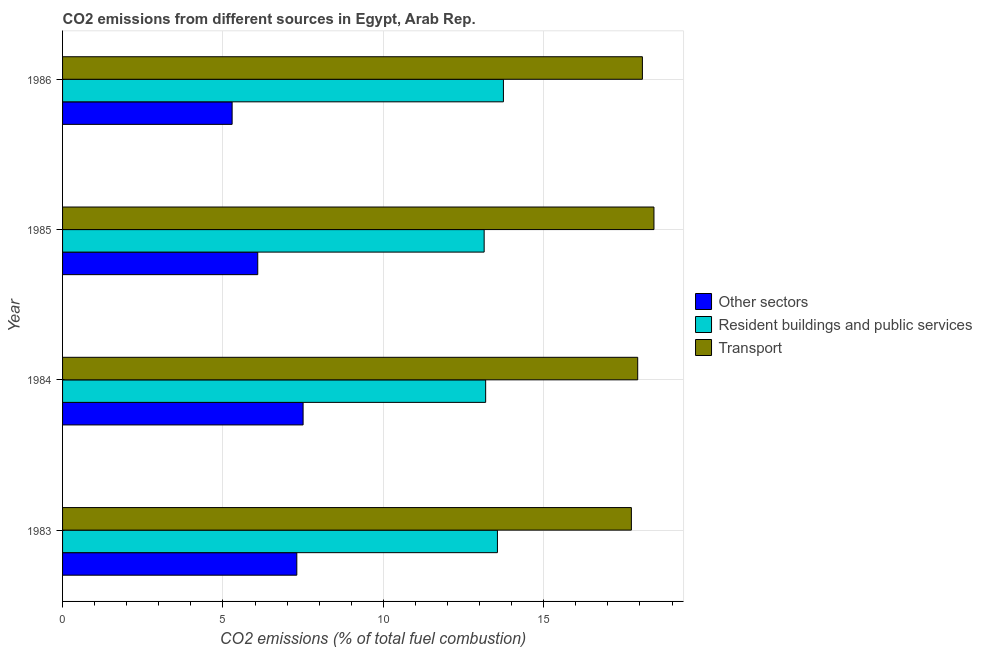Are the number of bars per tick equal to the number of legend labels?
Offer a terse response. Yes. How many bars are there on the 3rd tick from the top?
Offer a very short reply. 3. In how many cases, is the number of bars for a given year not equal to the number of legend labels?
Ensure brevity in your answer.  0. What is the percentage of co2 emissions from other sectors in 1986?
Your answer should be very brief. 5.29. Across all years, what is the maximum percentage of co2 emissions from other sectors?
Your answer should be compact. 7.5. Across all years, what is the minimum percentage of co2 emissions from resident buildings and public services?
Keep it short and to the point. 13.14. In which year was the percentage of co2 emissions from resident buildings and public services maximum?
Offer a terse response. 1986. In which year was the percentage of co2 emissions from transport minimum?
Ensure brevity in your answer.  1983. What is the total percentage of co2 emissions from other sectors in the graph?
Your answer should be very brief. 26.17. What is the difference between the percentage of co2 emissions from resident buildings and public services in 1983 and that in 1984?
Offer a very short reply. 0.37. What is the difference between the percentage of co2 emissions from resident buildings and public services in 1984 and the percentage of co2 emissions from other sectors in 1983?
Provide a succinct answer. 5.89. What is the average percentage of co2 emissions from resident buildings and public services per year?
Offer a very short reply. 13.41. In the year 1985, what is the difference between the percentage of co2 emissions from transport and percentage of co2 emissions from resident buildings and public services?
Make the answer very short. 5.29. What is the ratio of the percentage of co2 emissions from other sectors in 1984 to that in 1985?
Keep it short and to the point. 1.23. Is the difference between the percentage of co2 emissions from resident buildings and public services in 1983 and 1985 greater than the difference between the percentage of co2 emissions from transport in 1983 and 1985?
Your response must be concise. Yes. What is the difference between the highest and the second highest percentage of co2 emissions from resident buildings and public services?
Offer a terse response. 0.19. What is the difference between the highest and the lowest percentage of co2 emissions from resident buildings and public services?
Your response must be concise. 0.6. Is the sum of the percentage of co2 emissions from resident buildings and public services in 1985 and 1986 greater than the maximum percentage of co2 emissions from transport across all years?
Provide a short and direct response. Yes. What does the 1st bar from the top in 1986 represents?
Ensure brevity in your answer.  Transport. What does the 3rd bar from the bottom in 1985 represents?
Make the answer very short. Transport. How many bars are there?
Ensure brevity in your answer.  12. How many years are there in the graph?
Make the answer very short. 4. Are the values on the major ticks of X-axis written in scientific E-notation?
Provide a succinct answer. No. What is the title of the graph?
Provide a succinct answer. CO2 emissions from different sources in Egypt, Arab Rep. What is the label or title of the X-axis?
Provide a short and direct response. CO2 emissions (% of total fuel combustion). What is the label or title of the Y-axis?
Keep it short and to the point. Year. What is the CO2 emissions (% of total fuel combustion) in Other sectors in 1983?
Your response must be concise. 7.3. What is the CO2 emissions (% of total fuel combustion) in Resident buildings and public services in 1983?
Your response must be concise. 13.56. What is the CO2 emissions (% of total fuel combustion) in Transport in 1983?
Your answer should be compact. 17.73. What is the CO2 emissions (% of total fuel combustion) in Other sectors in 1984?
Ensure brevity in your answer.  7.5. What is the CO2 emissions (% of total fuel combustion) in Resident buildings and public services in 1984?
Offer a terse response. 13.19. What is the CO2 emissions (% of total fuel combustion) of Transport in 1984?
Offer a terse response. 17.93. What is the CO2 emissions (% of total fuel combustion) of Other sectors in 1985?
Give a very brief answer. 6.08. What is the CO2 emissions (% of total fuel combustion) in Resident buildings and public services in 1985?
Your answer should be very brief. 13.14. What is the CO2 emissions (% of total fuel combustion) of Transport in 1985?
Your response must be concise. 18.44. What is the CO2 emissions (% of total fuel combustion) of Other sectors in 1986?
Provide a short and direct response. 5.29. What is the CO2 emissions (% of total fuel combustion) of Resident buildings and public services in 1986?
Give a very brief answer. 13.74. What is the CO2 emissions (% of total fuel combustion) of Transport in 1986?
Make the answer very short. 18.08. Across all years, what is the maximum CO2 emissions (% of total fuel combustion) of Other sectors?
Make the answer very short. 7.5. Across all years, what is the maximum CO2 emissions (% of total fuel combustion) in Resident buildings and public services?
Give a very brief answer. 13.74. Across all years, what is the maximum CO2 emissions (% of total fuel combustion) in Transport?
Keep it short and to the point. 18.44. Across all years, what is the minimum CO2 emissions (% of total fuel combustion) in Other sectors?
Offer a very short reply. 5.29. Across all years, what is the minimum CO2 emissions (% of total fuel combustion) in Resident buildings and public services?
Give a very brief answer. 13.14. Across all years, what is the minimum CO2 emissions (% of total fuel combustion) of Transport?
Make the answer very short. 17.73. What is the total CO2 emissions (% of total fuel combustion) of Other sectors in the graph?
Provide a short and direct response. 26.17. What is the total CO2 emissions (% of total fuel combustion) of Resident buildings and public services in the graph?
Provide a short and direct response. 53.63. What is the total CO2 emissions (% of total fuel combustion) of Transport in the graph?
Your answer should be very brief. 72.17. What is the difference between the CO2 emissions (% of total fuel combustion) of Other sectors in 1983 and that in 1984?
Your response must be concise. -0.2. What is the difference between the CO2 emissions (% of total fuel combustion) in Resident buildings and public services in 1983 and that in 1984?
Offer a very short reply. 0.37. What is the difference between the CO2 emissions (% of total fuel combustion) in Transport in 1983 and that in 1984?
Provide a short and direct response. -0.2. What is the difference between the CO2 emissions (% of total fuel combustion) in Other sectors in 1983 and that in 1985?
Keep it short and to the point. 1.22. What is the difference between the CO2 emissions (% of total fuel combustion) of Resident buildings and public services in 1983 and that in 1985?
Your response must be concise. 0.41. What is the difference between the CO2 emissions (% of total fuel combustion) of Transport in 1983 and that in 1985?
Provide a short and direct response. -0.7. What is the difference between the CO2 emissions (% of total fuel combustion) of Other sectors in 1983 and that in 1986?
Offer a very short reply. 2.02. What is the difference between the CO2 emissions (% of total fuel combustion) in Resident buildings and public services in 1983 and that in 1986?
Provide a succinct answer. -0.19. What is the difference between the CO2 emissions (% of total fuel combustion) in Transport in 1983 and that in 1986?
Ensure brevity in your answer.  -0.34. What is the difference between the CO2 emissions (% of total fuel combustion) in Other sectors in 1984 and that in 1985?
Keep it short and to the point. 1.41. What is the difference between the CO2 emissions (% of total fuel combustion) of Resident buildings and public services in 1984 and that in 1985?
Provide a succinct answer. 0.05. What is the difference between the CO2 emissions (% of total fuel combustion) in Transport in 1984 and that in 1985?
Offer a terse response. -0.51. What is the difference between the CO2 emissions (% of total fuel combustion) of Other sectors in 1984 and that in 1986?
Offer a very short reply. 2.21. What is the difference between the CO2 emissions (% of total fuel combustion) in Resident buildings and public services in 1984 and that in 1986?
Your answer should be very brief. -0.55. What is the difference between the CO2 emissions (% of total fuel combustion) of Transport in 1984 and that in 1986?
Offer a very short reply. -0.15. What is the difference between the CO2 emissions (% of total fuel combustion) in Other sectors in 1985 and that in 1986?
Provide a short and direct response. 0.8. What is the difference between the CO2 emissions (% of total fuel combustion) of Resident buildings and public services in 1985 and that in 1986?
Offer a very short reply. -0.6. What is the difference between the CO2 emissions (% of total fuel combustion) of Transport in 1985 and that in 1986?
Offer a terse response. 0.36. What is the difference between the CO2 emissions (% of total fuel combustion) of Other sectors in 1983 and the CO2 emissions (% of total fuel combustion) of Resident buildings and public services in 1984?
Provide a succinct answer. -5.89. What is the difference between the CO2 emissions (% of total fuel combustion) in Other sectors in 1983 and the CO2 emissions (% of total fuel combustion) in Transport in 1984?
Give a very brief answer. -10.63. What is the difference between the CO2 emissions (% of total fuel combustion) of Resident buildings and public services in 1983 and the CO2 emissions (% of total fuel combustion) of Transport in 1984?
Ensure brevity in your answer.  -4.37. What is the difference between the CO2 emissions (% of total fuel combustion) in Other sectors in 1983 and the CO2 emissions (% of total fuel combustion) in Resident buildings and public services in 1985?
Your response must be concise. -5.84. What is the difference between the CO2 emissions (% of total fuel combustion) of Other sectors in 1983 and the CO2 emissions (% of total fuel combustion) of Transport in 1985?
Provide a short and direct response. -11.13. What is the difference between the CO2 emissions (% of total fuel combustion) in Resident buildings and public services in 1983 and the CO2 emissions (% of total fuel combustion) in Transport in 1985?
Keep it short and to the point. -4.88. What is the difference between the CO2 emissions (% of total fuel combustion) in Other sectors in 1983 and the CO2 emissions (% of total fuel combustion) in Resident buildings and public services in 1986?
Give a very brief answer. -6.44. What is the difference between the CO2 emissions (% of total fuel combustion) of Other sectors in 1983 and the CO2 emissions (% of total fuel combustion) of Transport in 1986?
Offer a terse response. -10.77. What is the difference between the CO2 emissions (% of total fuel combustion) in Resident buildings and public services in 1983 and the CO2 emissions (% of total fuel combustion) in Transport in 1986?
Offer a very short reply. -4.52. What is the difference between the CO2 emissions (% of total fuel combustion) of Other sectors in 1984 and the CO2 emissions (% of total fuel combustion) of Resident buildings and public services in 1985?
Give a very brief answer. -5.64. What is the difference between the CO2 emissions (% of total fuel combustion) of Other sectors in 1984 and the CO2 emissions (% of total fuel combustion) of Transport in 1985?
Offer a very short reply. -10.94. What is the difference between the CO2 emissions (% of total fuel combustion) of Resident buildings and public services in 1984 and the CO2 emissions (% of total fuel combustion) of Transport in 1985?
Give a very brief answer. -5.25. What is the difference between the CO2 emissions (% of total fuel combustion) in Other sectors in 1984 and the CO2 emissions (% of total fuel combustion) in Resident buildings and public services in 1986?
Your answer should be very brief. -6.24. What is the difference between the CO2 emissions (% of total fuel combustion) in Other sectors in 1984 and the CO2 emissions (% of total fuel combustion) in Transport in 1986?
Offer a terse response. -10.58. What is the difference between the CO2 emissions (% of total fuel combustion) in Resident buildings and public services in 1984 and the CO2 emissions (% of total fuel combustion) in Transport in 1986?
Your answer should be compact. -4.89. What is the difference between the CO2 emissions (% of total fuel combustion) in Other sectors in 1985 and the CO2 emissions (% of total fuel combustion) in Resident buildings and public services in 1986?
Keep it short and to the point. -7.66. What is the difference between the CO2 emissions (% of total fuel combustion) in Other sectors in 1985 and the CO2 emissions (% of total fuel combustion) in Transport in 1986?
Give a very brief answer. -11.99. What is the difference between the CO2 emissions (% of total fuel combustion) in Resident buildings and public services in 1985 and the CO2 emissions (% of total fuel combustion) in Transport in 1986?
Offer a very short reply. -4.93. What is the average CO2 emissions (% of total fuel combustion) of Other sectors per year?
Your answer should be compact. 6.54. What is the average CO2 emissions (% of total fuel combustion) of Resident buildings and public services per year?
Offer a terse response. 13.41. What is the average CO2 emissions (% of total fuel combustion) in Transport per year?
Your response must be concise. 18.04. In the year 1983, what is the difference between the CO2 emissions (% of total fuel combustion) in Other sectors and CO2 emissions (% of total fuel combustion) in Resident buildings and public services?
Provide a succinct answer. -6.25. In the year 1983, what is the difference between the CO2 emissions (% of total fuel combustion) of Other sectors and CO2 emissions (% of total fuel combustion) of Transport?
Your answer should be very brief. -10.43. In the year 1983, what is the difference between the CO2 emissions (% of total fuel combustion) of Resident buildings and public services and CO2 emissions (% of total fuel combustion) of Transport?
Offer a very short reply. -4.18. In the year 1984, what is the difference between the CO2 emissions (% of total fuel combustion) in Other sectors and CO2 emissions (% of total fuel combustion) in Resident buildings and public services?
Offer a terse response. -5.69. In the year 1984, what is the difference between the CO2 emissions (% of total fuel combustion) of Other sectors and CO2 emissions (% of total fuel combustion) of Transport?
Your answer should be very brief. -10.43. In the year 1984, what is the difference between the CO2 emissions (% of total fuel combustion) in Resident buildings and public services and CO2 emissions (% of total fuel combustion) in Transport?
Ensure brevity in your answer.  -4.74. In the year 1985, what is the difference between the CO2 emissions (% of total fuel combustion) of Other sectors and CO2 emissions (% of total fuel combustion) of Resident buildings and public services?
Provide a short and direct response. -7.06. In the year 1985, what is the difference between the CO2 emissions (% of total fuel combustion) of Other sectors and CO2 emissions (% of total fuel combustion) of Transport?
Offer a very short reply. -12.35. In the year 1985, what is the difference between the CO2 emissions (% of total fuel combustion) in Resident buildings and public services and CO2 emissions (% of total fuel combustion) in Transport?
Provide a succinct answer. -5.29. In the year 1986, what is the difference between the CO2 emissions (% of total fuel combustion) of Other sectors and CO2 emissions (% of total fuel combustion) of Resident buildings and public services?
Give a very brief answer. -8.46. In the year 1986, what is the difference between the CO2 emissions (% of total fuel combustion) of Other sectors and CO2 emissions (% of total fuel combustion) of Transport?
Ensure brevity in your answer.  -12.79. In the year 1986, what is the difference between the CO2 emissions (% of total fuel combustion) in Resident buildings and public services and CO2 emissions (% of total fuel combustion) in Transport?
Your answer should be very brief. -4.33. What is the ratio of the CO2 emissions (% of total fuel combustion) in Other sectors in 1983 to that in 1984?
Provide a succinct answer. 0.97. What is the ratio of the CO2 emissions (% of total fuel combustion) of Resident buildings and public services in 1983 to that in 1984?
Your answer should be very brief. 1.03. What is the ratio of the CO2 emissions (% of total fuel combustion) in Other sectors in 1983 to that in 1985?
Your answer should be compact. 1.2. What is the ratio of the CO2 emissions (% of total fuel combustion) of Resident buildings and public services in 1983 to that in 1985?
Offer a very short reply. 1.03. What is the ratio of the CO2 emissions (% of total fuel combustion) of Transport in 1983 to that in 1985?
Offer a terse response. 0.96. What is the ratio of the CO2 emissions (% of total fuel combustion) in Other sectors in 1983 to that in 1986?
Your answer should be compact. 1.38. What is the ratio of the CO2 emissions (% of total fuel combustion) of Resident buildings and public services in 1983 to that in 1986?
Offer a terse response. 0.99. What is the ratio of the CO2 emissions (% of total fuel combustion) of Other sectors in 1984 to that in 1985?
Your answer should be compact. 1.23. What is the ratio of the CO2 emissions (% of total fuel combustion) in Resident buildings and public services in 1984 to that in 1985?
Keep it short and to the point. 1. What is the ratio of the CO2 emissions (% of total fuel combustion) of Transport in 1984 to that in 1985?
Your answer should be very brief. 0.97. What is the ratio of the CO2 emissions (% of total fuel combustion) in Other sectors in 1984 to that in 1986?
Give a very brief answer. 1.42. What is the ratio of the CO2 emissions (% of total fuel combustion) of Resident buildings and public services in 1984 to that in 1986?
Your response must be concise. 0.96. What is the ratio of the CO2 emissions (% of total fuel combustion) in Transport in 1984 to that in 1986?
Offer a very short reply. 0.99. What is the ratio of the CO2 emissions (% of total fuel combustion) of Other sectors in 1985 to that in 1986?
Offer a terse response. 1.15. What is the ratio of the CO2 emissions (% of total fuel combustion) in Resident buildings and public services in 1985 to that in 1986?
Your answer should be compact. 0.96. What is the ratio of the CO2 emissions (% of total fuel combustion) of Transport in 1985 to that in 1986?
Offer a very short reply. 1.02. What is the difference between the highest and the second highest CO2 emissions (% of total fuel combustion) of Other sectors?
Your answer should be compact. 0.2. What is the difference between the highest and the second highest CO2 emissions (% of total fuel combustion) in Resident buildings and public services?
Give a very brief answer. 0.19. What is the difference between the highest and the second highest CO2 emissions (% of total fuel combustion) in Transport?
Give a very brief answer. 0.36. What is the difference between the highest and the lowest CO2 emissions (% of total fuel combustion) in Other sectors?
Your answer should be compact. 2.21. What is the difference between the highest and the lowest CO2 emissions (% of total fuel combustion) of Resident buildings and public services?
Your answer should be compact. 0.6. What is the difference between the highest and the lowest CO2 emissions (% of total fuel combustion) of Transport?
Your answer should be compact. 0.7. 